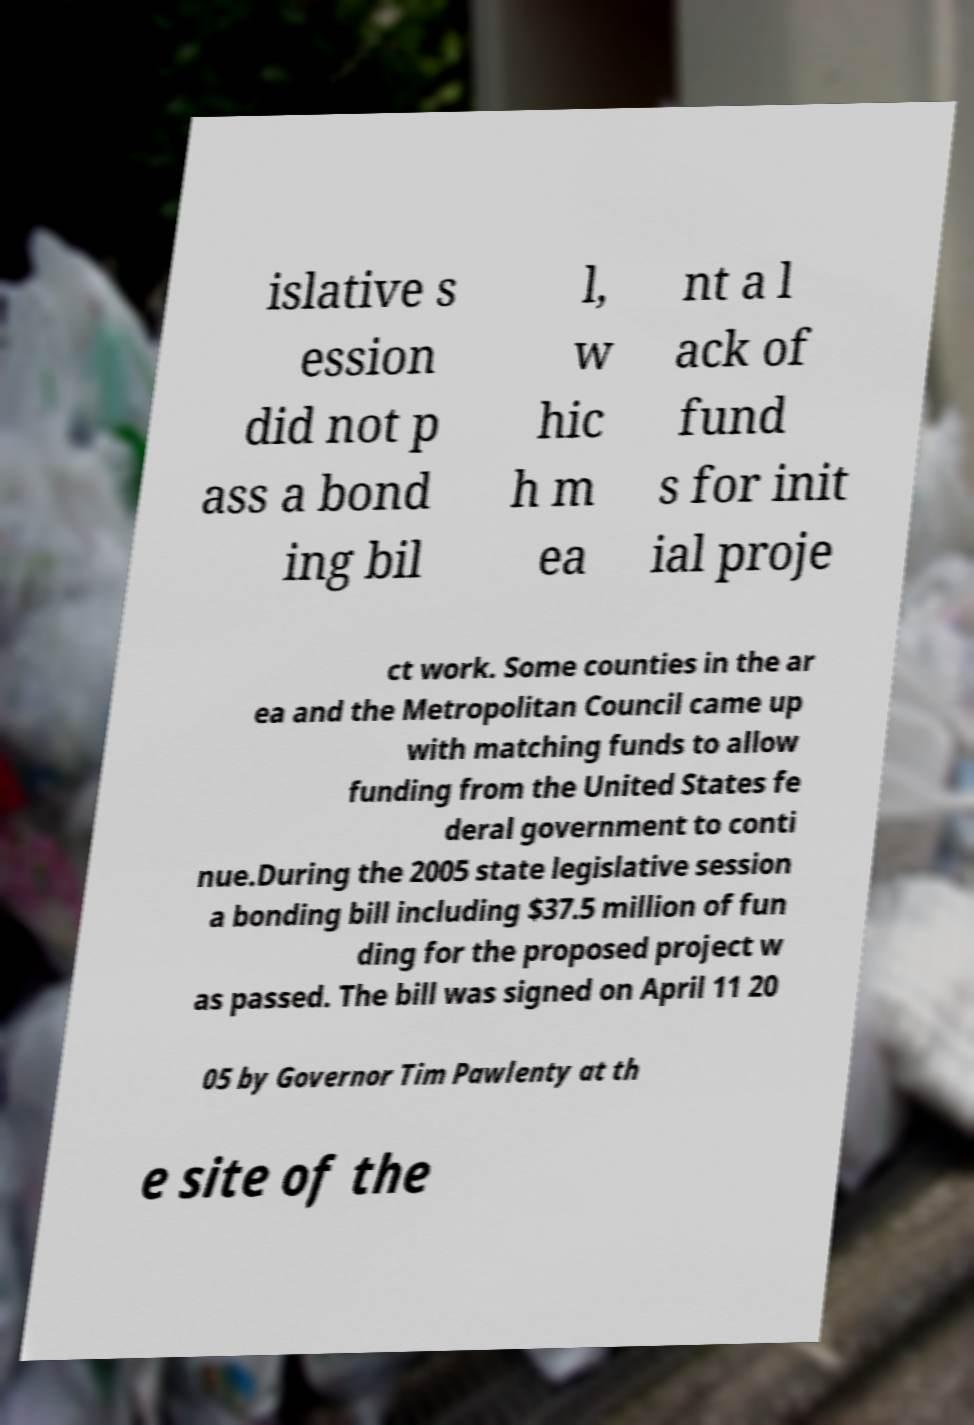Can you accurately transcribe the text from the provided image for me? islative s ession did not p ass a bond ing bil l, w hic h m ea nt a l ack of fund s for init ial proje ct work. Some counties in the ar ea and the Metropolitan Council came up with matching funds to allow funding from the United States fe deral government to conti nue.During the 2005 state legislative session a bonding bill including $37.5 million of fun ding for the proposed project w as passed. The bill was signed on April 11 20 05 by Governor Tim Pawlenty at th e site of the 